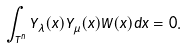<formula> <loc_0><loc_0><loc_500><loc_500>\int _ { T ^ { n } } Y _ { \lambda } ( x ) Y _ { \mu } ( x ) W ( x ) d x = 0 .</formula> 